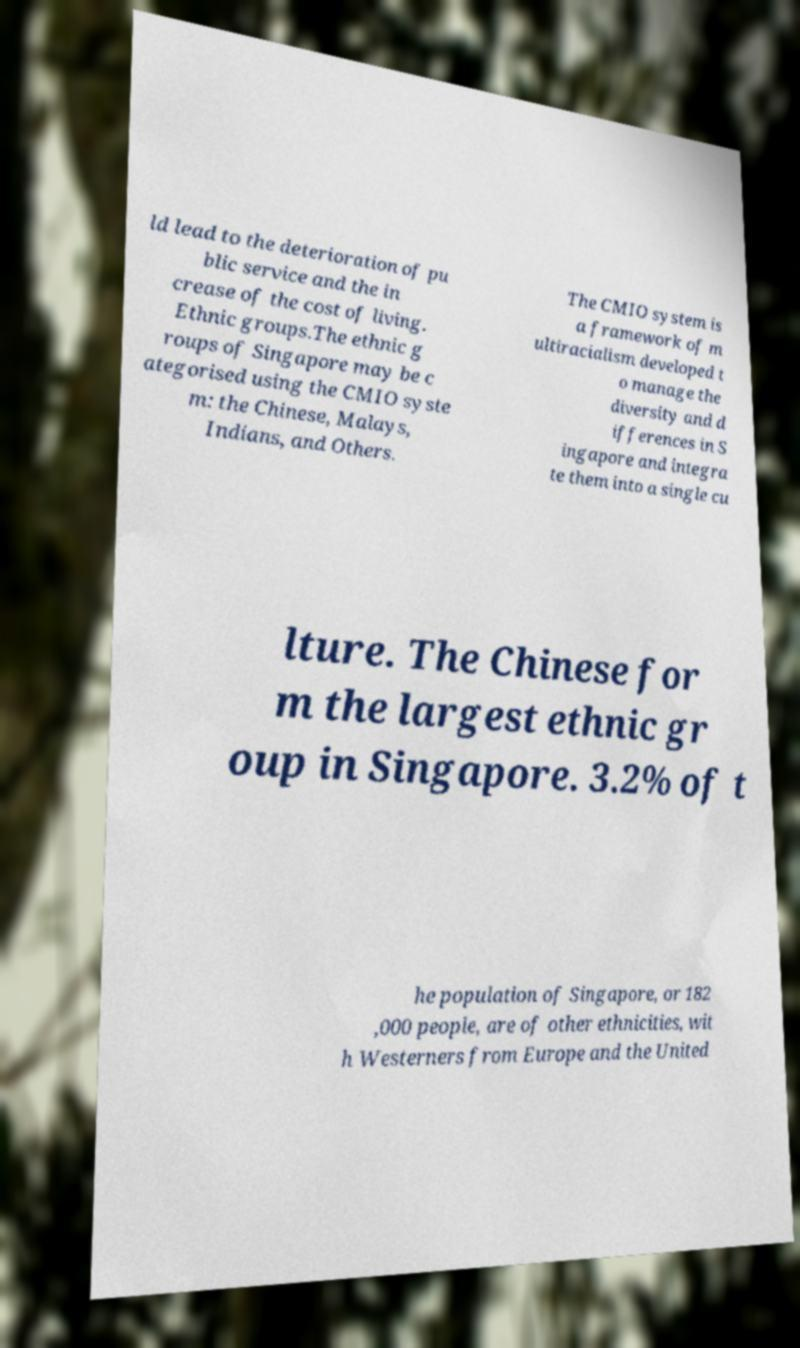There's text embedded in this image that I need extracted. Can you transcribe it verbatim? ld lead to the deterioration of pu blic service and the in crease of the cost of living. Ethnic groups.The ethnic g roups of Singapore may be c ategorised using the CMIO syste m: the Chinese, Malays, Indians, and Others. The CMIO system is a framework of m ultiracialism developed t o manage the diversity and d ifferences in S ingapore and integra te them into a single cu lture. The Chinese for m the largest ethnic gr oup in Singapore. 3.2% of t he population of Singapore, or 182 ,000 people, are of other ethnicities, wit h Westerners from Europe and the United 